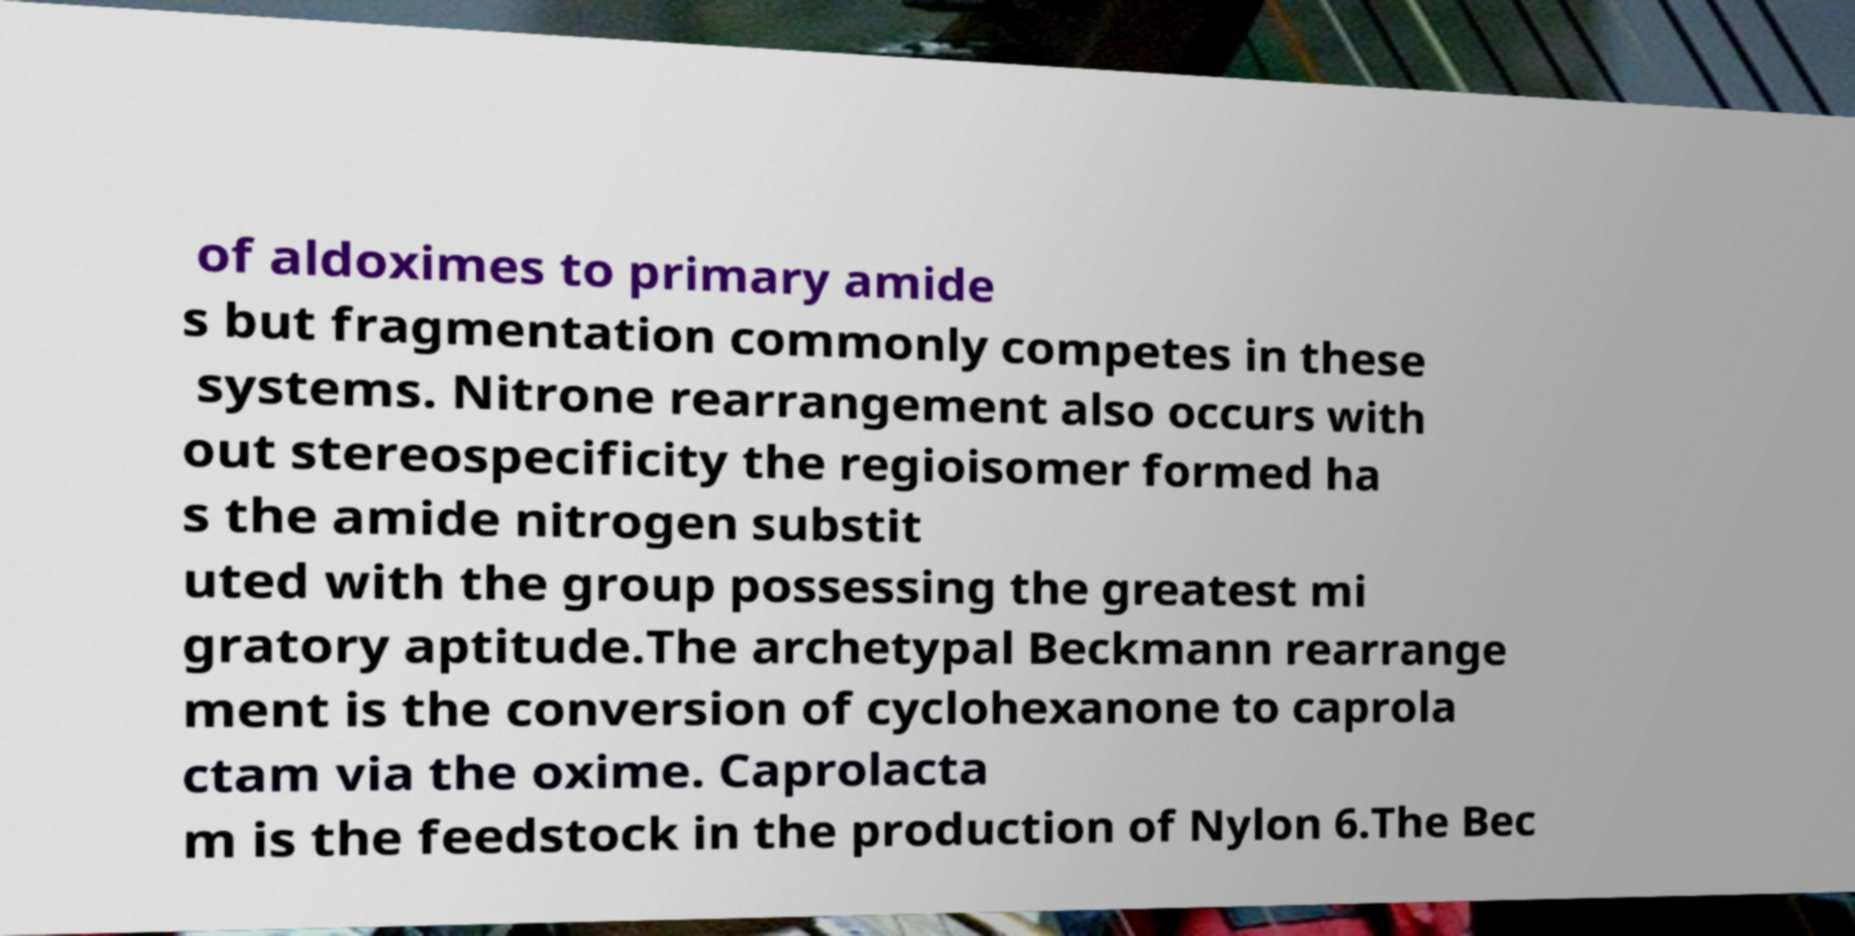There's text embedded in this image that I need extracted. Can you transcribe it verbatim? of aldoximes to primary amide s but fragmentation commonly competes in these systems. Nitrone rearrangement also occurs with out stereospecificity the regioisomer formed ha s the amide nitrogen substit uted with the group possessing the greatest mi gratory aptitude.The archetypal Beckmann rearrange ment is the conversion of cyclohexanone to caprola ctam via the oxime. Caprolacta m is the feedstock in the production of Nylon 6.The Bec 